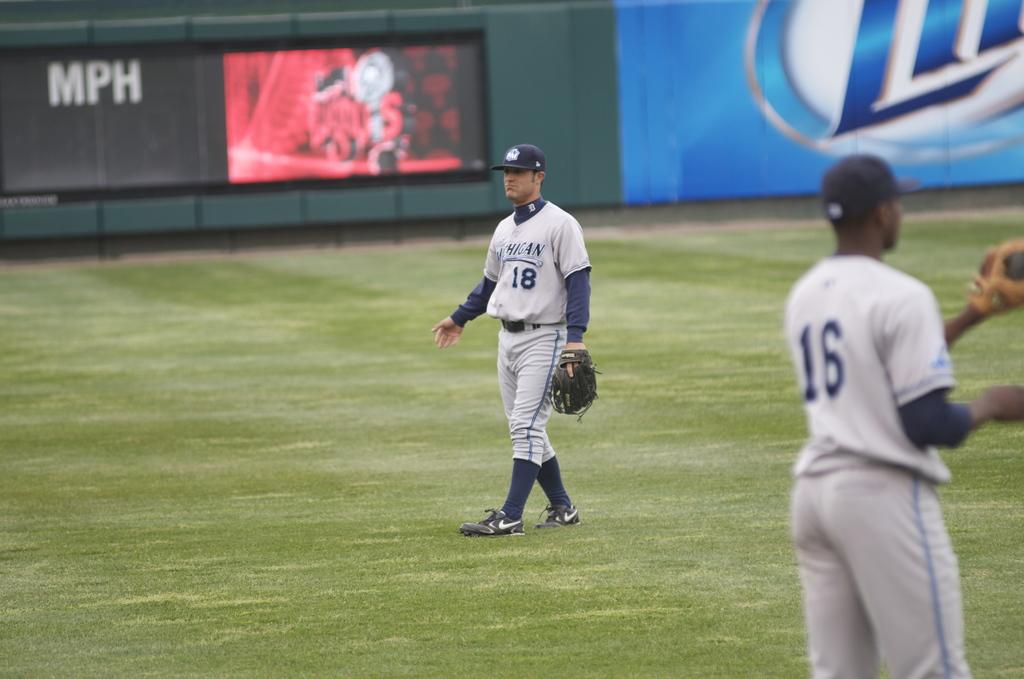Is player 18 on the field?
Provide a short and direct response. Yes. What is wrote above the number 18 on the jersey?
Make the answer very short. Michigan. 